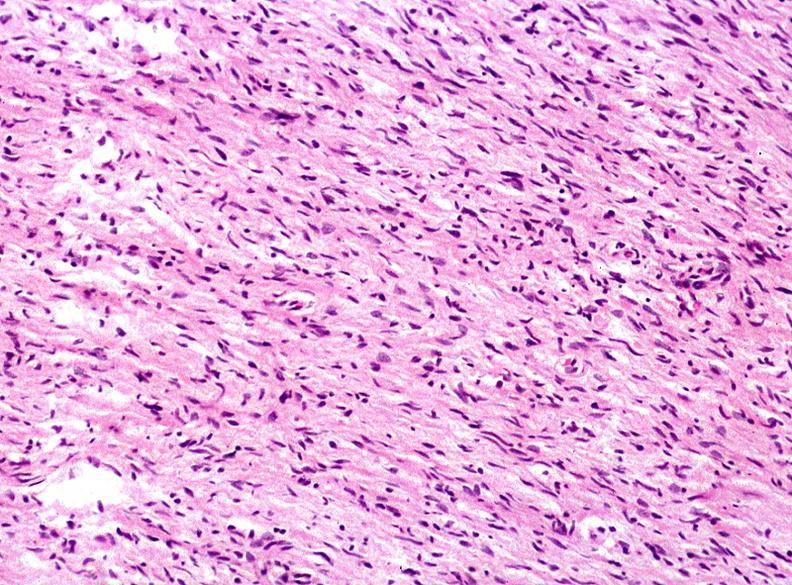what does this image show?
Answer the question using a single word or phrase. Skin 